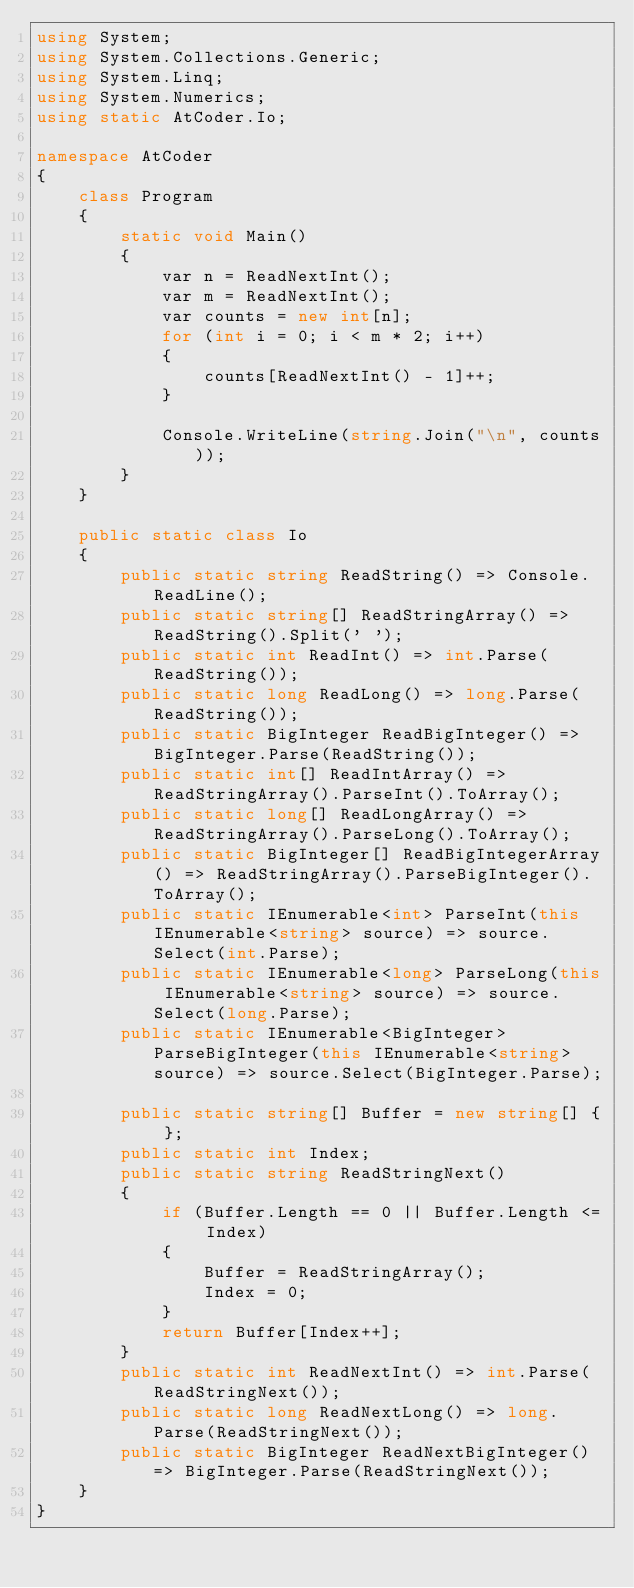Convert code to text. <code><loc_0><loc_0><loc_500><loc_500><_C#_>using System;
using System.Collections.Generic;
using System.Linq;
using System.Numerics;
using static AtCoder.Io;

namespace AtCoder
{
    class Program
    {
        static void Main()
        {
            var n = ReadNextInt();
            var m = ReadNextInt();
            var counts = new int[n];
            for (int i = 0; i < m * 2; i++)
            {
                counts[ReadNextInt() - 1]++;
            }

            Console.WriteLine(string.Join("\n", counts));
        }
    }

    public static class Io
    {
        public static string ReadString() => Console.ReadLine();
        public static string[] ReadStringArray() => ReadString().Split(' ');
        public static int ReadInt() => int.Parse(ReadString());
        public static long ReadLong() => long.Parse(ReadString());
        public static BigInteger ReadBigInteger() => BigInteger.Parse(ReadString());
        public static int[] ReadIntArray() => ReadStringArray().ParseInt().ToArray();
        public static long[] ReadLongArray() => ReadStringArray().ParseLong().ToArray();
        public static BigInteger[] ReadBigIntegerArray() => ReadStringArray().ParseBigInteger().ToArray();
        public static IEnumerable<int> ParseInt(this IEnumerable<string> source) => source.Select(int.Parse);
        public static IEnumerable<long> ParseLong(this IEnumerable<string> source) => source.Select(long.Parse);
        public static IEnumerable<BigInteger> ParseBigInteger(this IEnumerable<string> source) => source.Select(BigInteger.Parse);

        public static string[] Buffer = new string[] { };
        public static int Index;
        public static string ReadStringNext()
        {
            if (Buffer.Length == 0 || Buffer.Length <= Index)
            {
                Buffer = ReadStringArray();
                Index = 0;
            }
            return Buffer[Index++];
        }
        public static int ReadNextInt() => int.Parse(ReadStringNext());
        public static long ReadNextLong() => long.Parse(ReadStringNext());
        public static BigInteger ReadNextBigInteger() => BigInteger.Parse(ReadStringNext());
    }
}
</code> 